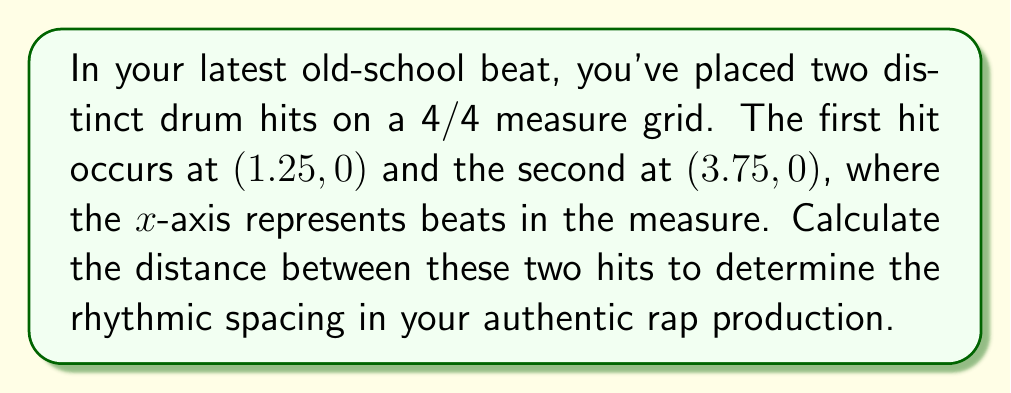What is the answer to this math problem? To calculate the distance between two points in a 2D plane, we use the distance formula derived from the Pythagorean theorem:

$$ d = \sqrt{(x_2 - x_1)^2 + (y_2 - y_1)^2} $$

Where $(x_1, y_1)$ is the first point and $(x_2, y_2)$ is the second point.

In this case:
$(x_1, y_1) = (1.25, 0)$
$(x_2, y_2) = (3.75, 0)$

Substituting these values into the formula:

$$ d = \sqrt{(3.75 - 1.25)^2 + (0 - 0)^2} $$

Simplifying:
$$ d = \sqrt{(2.5)^2 + 0^2} $$
$$ d = \sqrt{6.25} $$

Calculating the square root:
$$ d = 2.5 $$

The distance between the two drum hits is 2.5 beats, which is exactly half the measure in 4/4 time, creating a strong, syncopated rhythm typical of old-school rap beats.
Answer: $2.5$ beats 